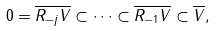Convert formula to latex. <formula><loc_0><loc_0><loc_500><loc_500>0 = \overline { R _ { - j } V } \subset \cdots \subset \overline { R _ { - 1 } V } \subset \overline { V } ,</formula> 